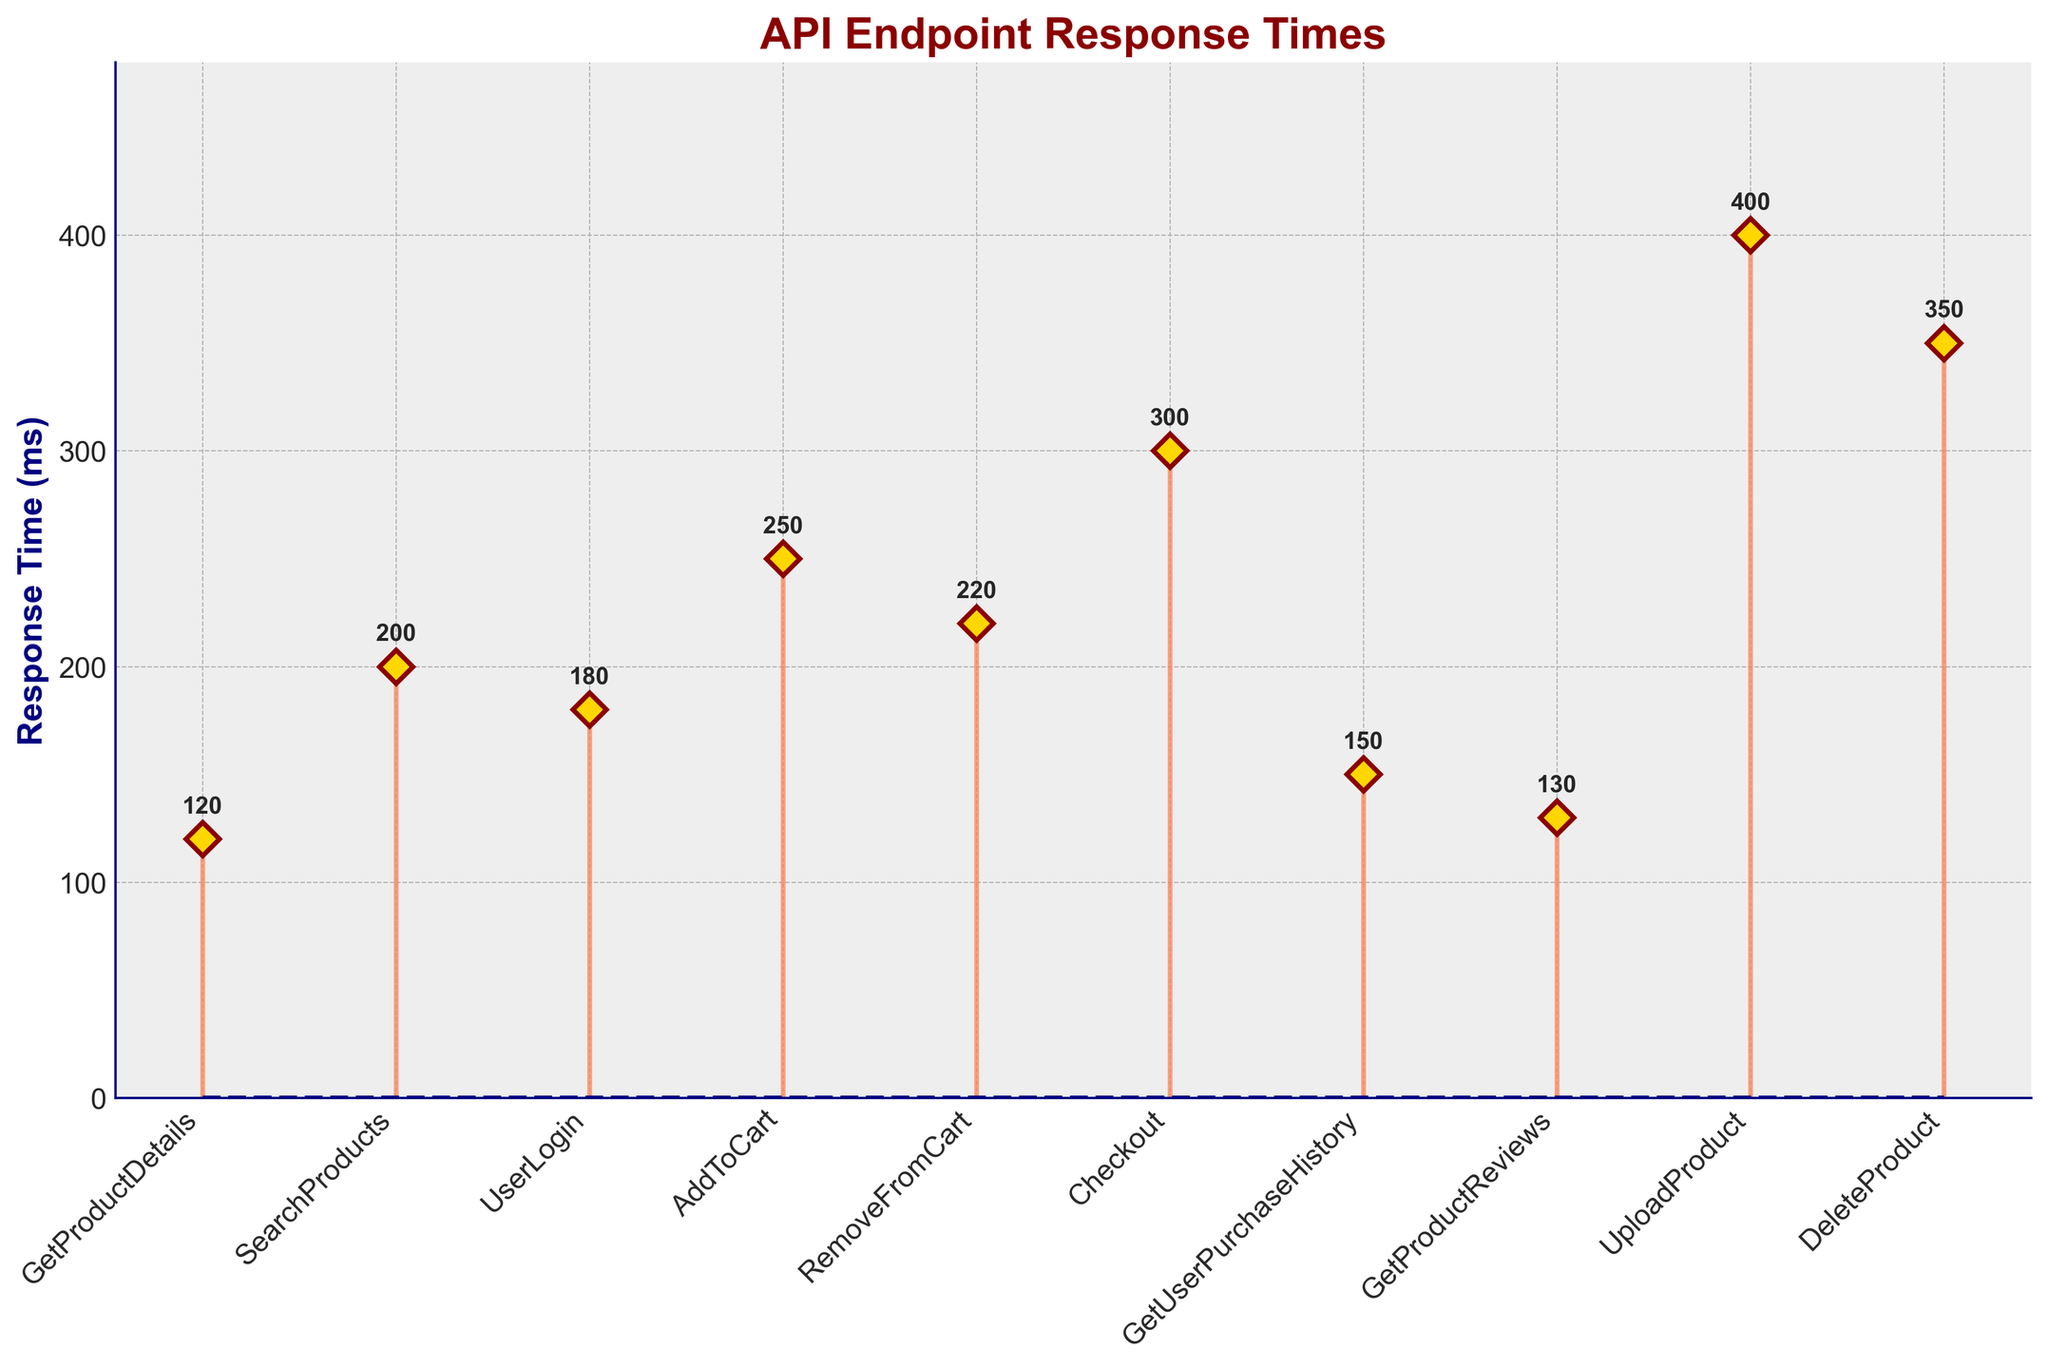What is the title of the stem plot? The title is displayed at the top of the plot and is typically larger and bolder than other text elements to catch the viewer's attention.
Answer: API Endpoint Response Times How many API endpoints are shown in the stem plot? Count the number of data points (stems) represented along the horizontal axis.
Answer: 10 What is the range of response times shown in the plot? The range is determined by identifying the lowest and highest values on the vertical axis (Response Time).
Answer: 120 ms to 400 ms Which API endpoint has the highest response time? Identify the API endpoint with the stem that extends to the highest point on the Response Time axis.
Answer: UploadProduct What is the response time for the UserLogin endpoint? Locate the stem corresponding to the UserLogin endpoint and read its height on the Response Time axis.
Answer: 180 ms Which API endpoint has the lowest response time? Identify the API endpoint with the shortest stem on the Response Time axis.
Answer: GetProductDetails What is the average response time across all API endpoints? Sum all the response times and then divide by the number of endpoints: (120 + 200 + 180 + 250 + 220 + 300 + 150 + 130 + 400 + 350)/10 = 230 ms
Answer: 230 ms How many API endpoints have a response time greater than 200 ms? Count the number of stems that extend beyond the 200 ms mark on the Response Time axis.
Answer: 6 What is the difference in response time between the Checkout and AddToCart endpoints? Subtract the response time of AddToCart from the response time of Checkout: 300 ms - 250 ms = 50 ms
Answer: 50 ms Which has a lower response time, GetProductReviews or GetUserPurchaseHistory endpoint? Compare the heights of the stems for these two endpoints on the Response Time axis.
Answer: GetProductReviews 